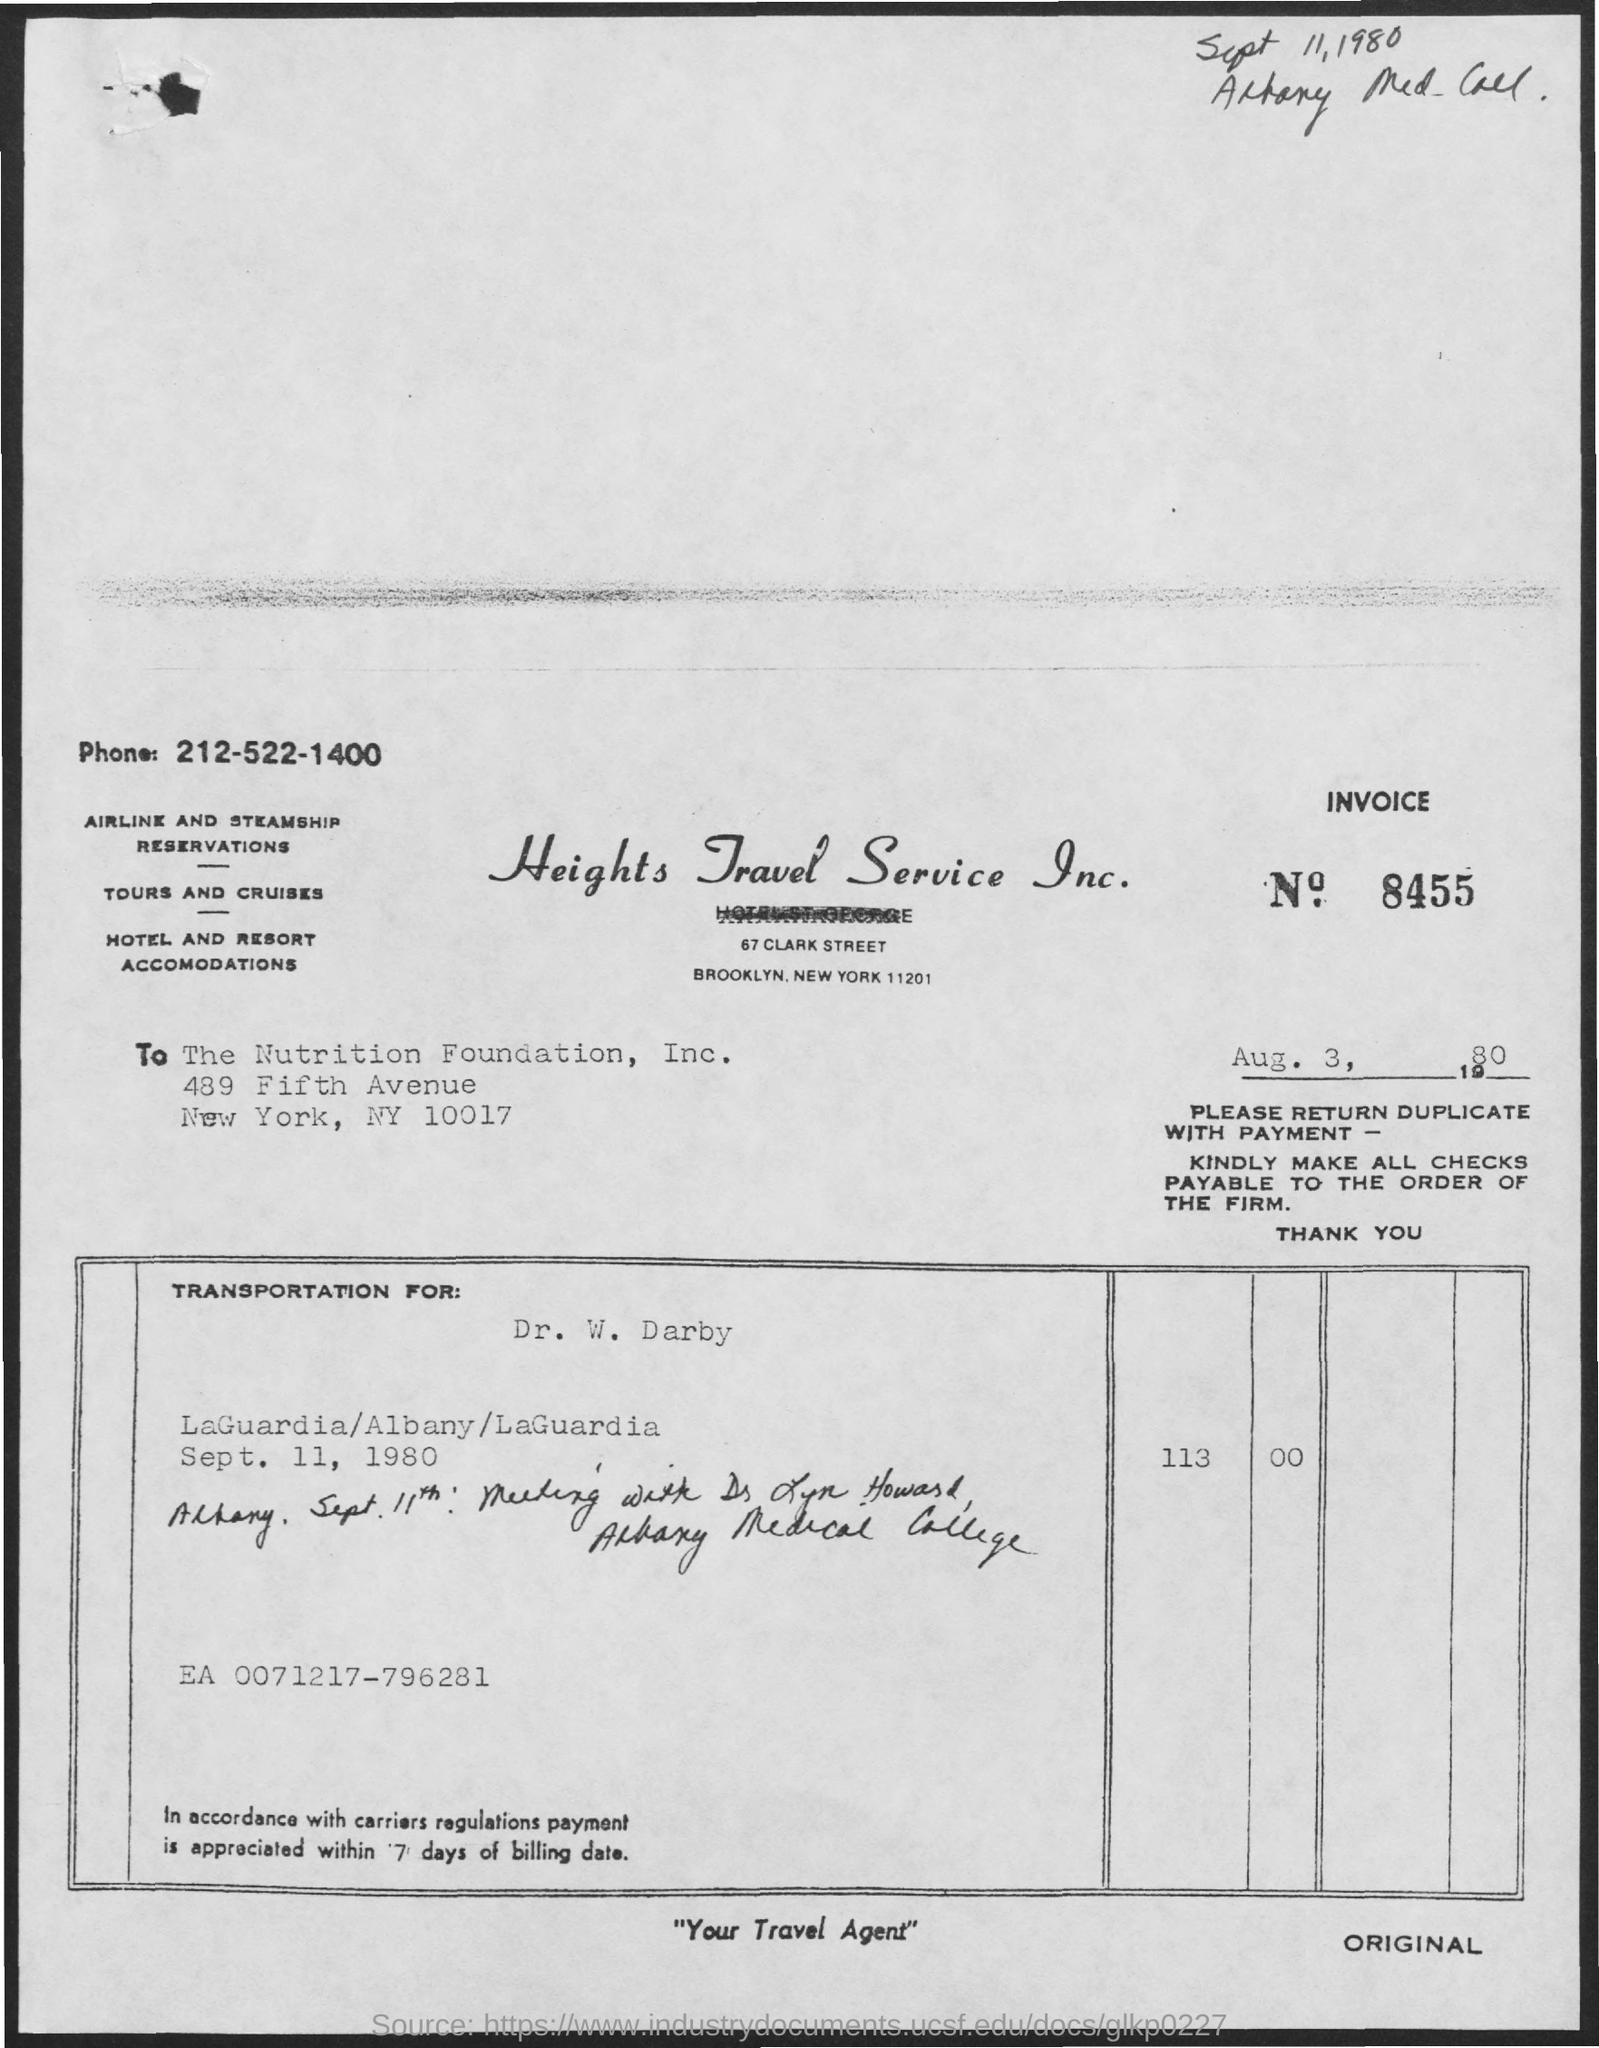Mention a couple of crucial points in this snapshot. Heights Travel Service Inc. is the name of the company. The invoice number is 8455. 